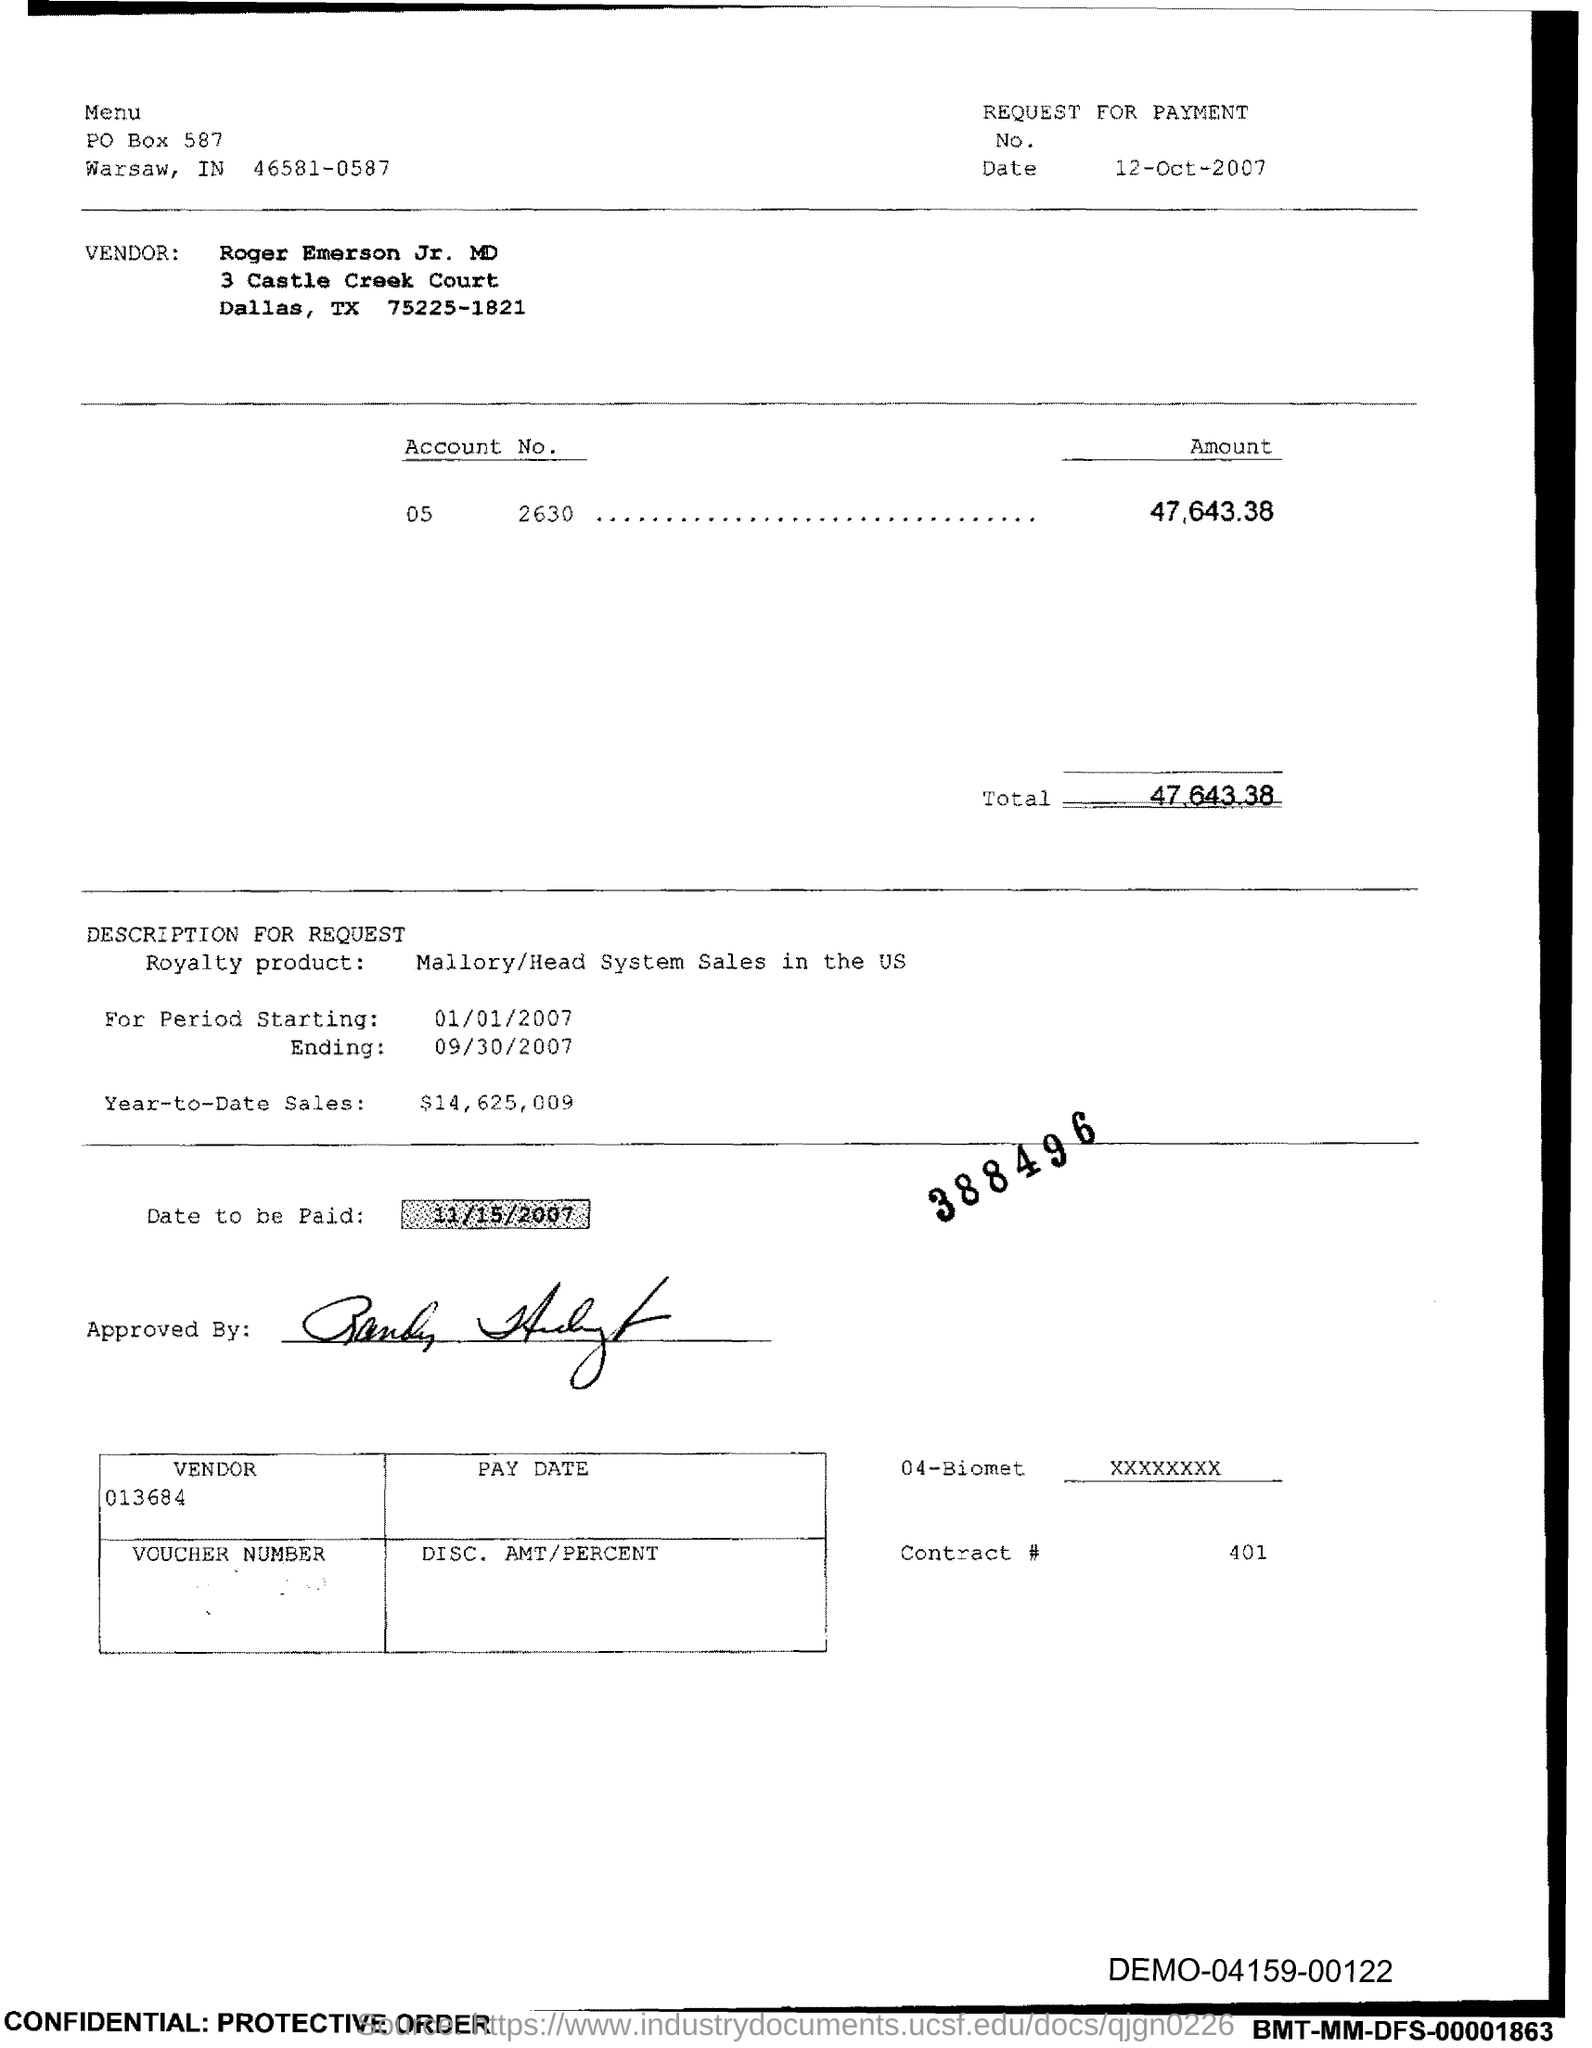What is the Total?
Keep it short and to the point. 47,643.38. What is the Contract # Number?
Your answer should be very brief. 401. What is the PO Box Number mentioned in the document?
Ensure brevity in your answer.  587. 